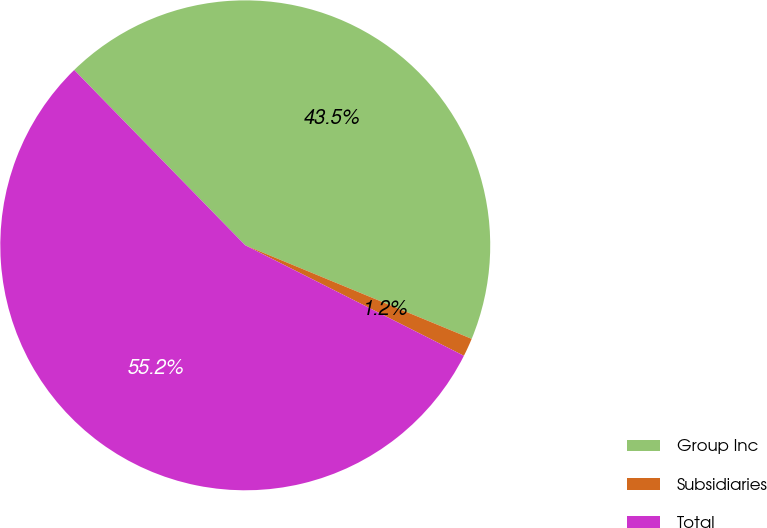Convert chart to OTSL. <chart><loc_0><loc_0><loc_500><loc_500><pie_chart><fcel>Group Inc<fcel>Subsidiaries<fcel>Total<nl><fcel>43.54%<fcel>1.21%<fcel>55.25%<nl></chart> 